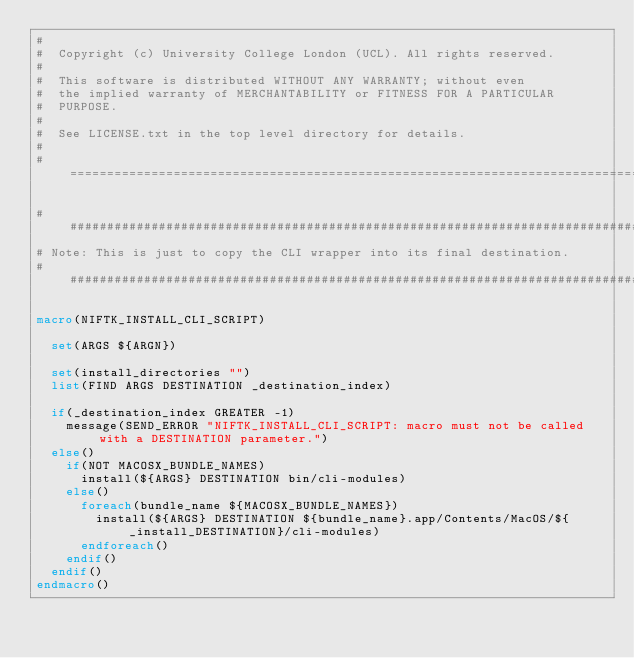<code> <loc_0><loc_0><loc_500><loc_500><_CMake_>#
#  Copyright (c) University College London (UCL). All rights reserved.
#
#  This software is distributed WITHOUT ANY WARRANTY; without even
#  the implied warranty of MERCHANTABILITY or FITNESS FOR A PARTICULAR
#  PURPOSE.
#
#  See LICENSE.txt in the top level directory for details.
#
#============================================================================*/

####################################################################################
# Note: This is just to copy the CLI wrapper into its final destination.
####################################################################################

macro(NIFTK_INSTALL_CLI_SCRIPT)

  set(ARGS ${ARGN})
 
  set(install_directories "")
  list(FIND ARGS DESTINATION _destination_index)
  
  if(_destination_index GREATER -1)
    message(SEND_ERROR "NIFTK_INSTALL_CLI_SCRIPT: macro must not be called with a DESTINATION parameter.")
  else()
    if(NOT MACOSX_BUNDLE_NAMES)
      install(${ARGS} DESTINATION bin/cli-modules)
    else()
      foreach(bundle_name ${MACOSX_BUNDLE_NAMES})
        install(${ARGS} DESTINATION ${bundle_name}.app/Contents/MacOS/${_install_DESTINATION}/cli-modules)
      endforeach()
    endif()
  endif()
endmacro()
</code> 